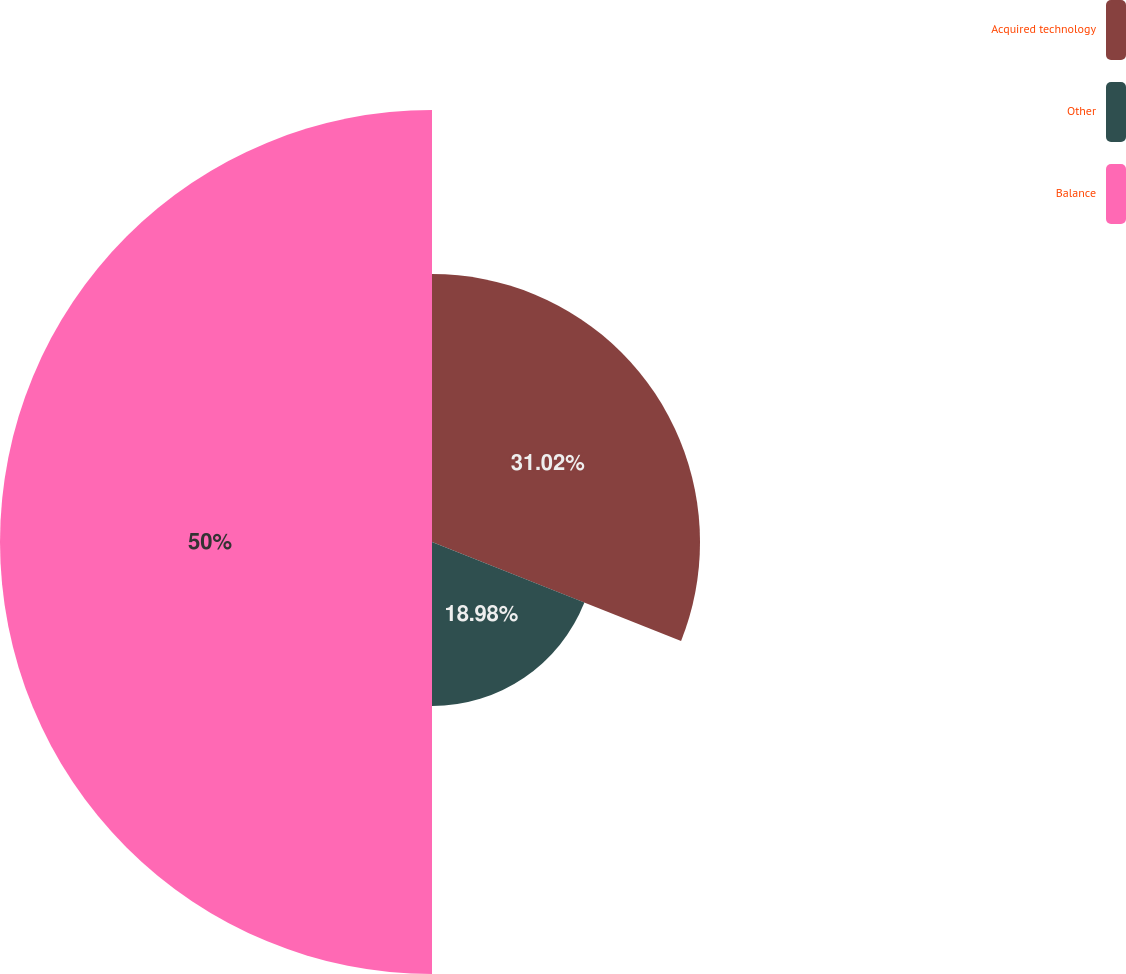<chart> <loc_0><loc_0><loc_500><loc_500><pie_chart><fcel>Acquired technology<fcel>Other<fcel>Balance<nl><fcel>31.02%<fcel>18.98%<fcel>50.0%<nl></chart> 